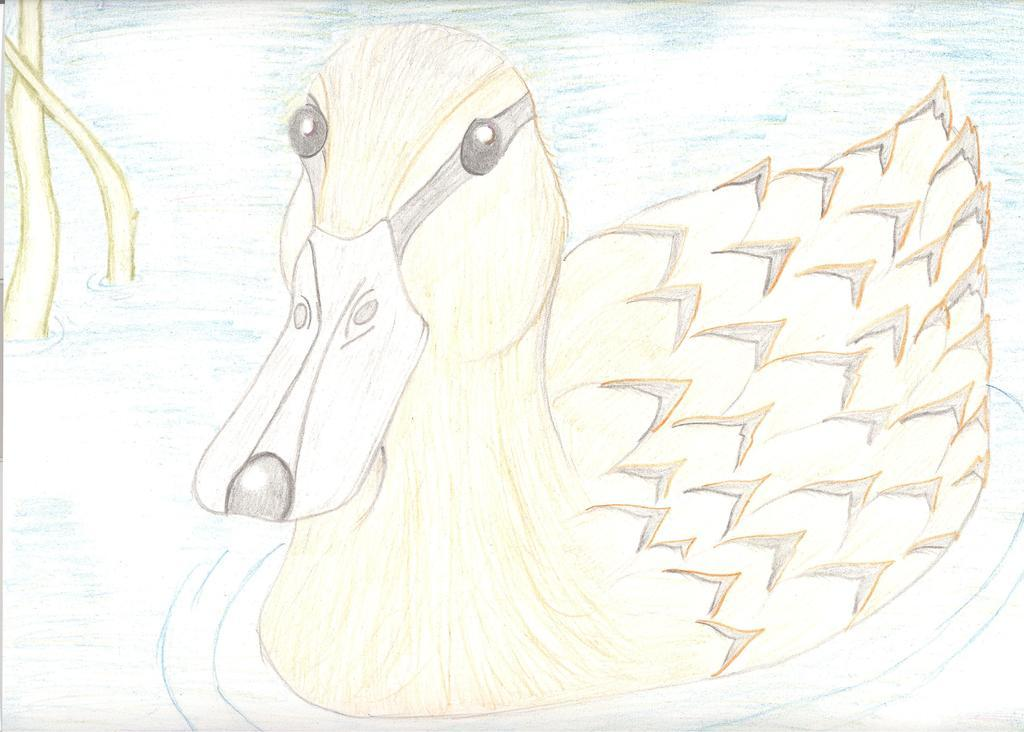What is the main subject of the image? The main subject of the image is an art of a duck. How is the duck depicted in the image? The duck is depicted as swimming in the water. Where is the sink located in the image? There is no sink present in the image. What type of van is parked near the duck in the image? There is no van present in the image. 